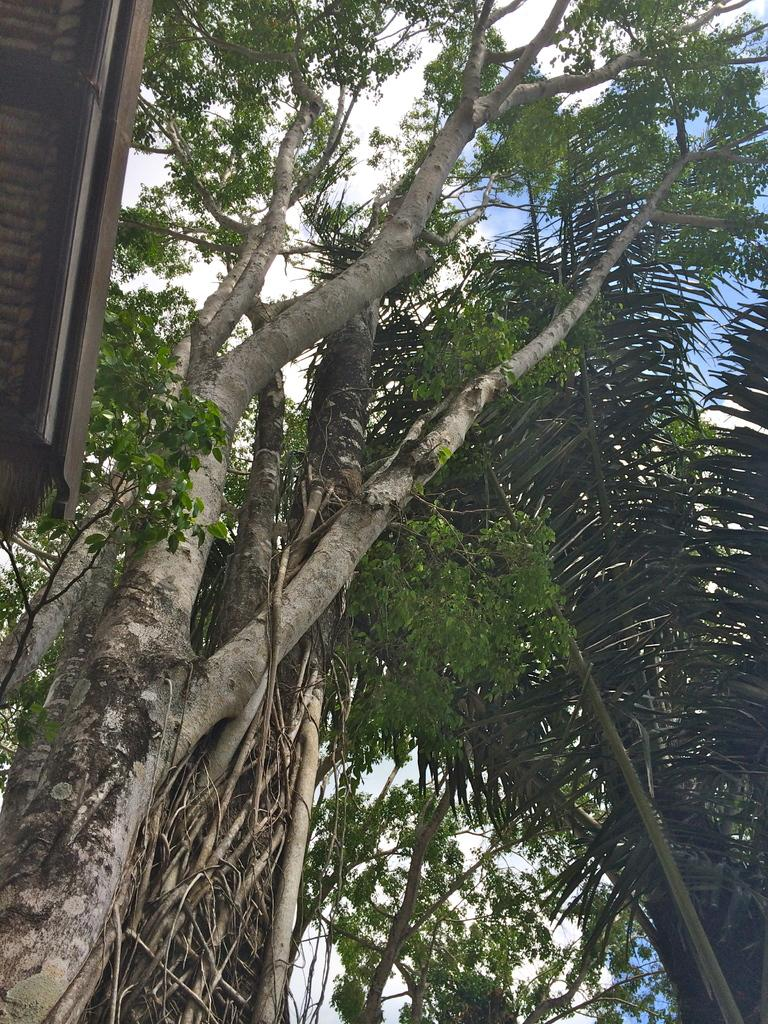What type of vegetation is present in the image? There are many trees in the image. What structure can be seen on the left side of the image? There is a shed on the left side of the image. What is visible at the top of the image? The sky is visible at the top of the image. What can be observed in the sky? Clouds are present in the sky. Where is the nest located in the image? There is no nest present in the image. What can be copied from the image? The image cannot be copied directly, but it can be described or recreated based on the details provided. 